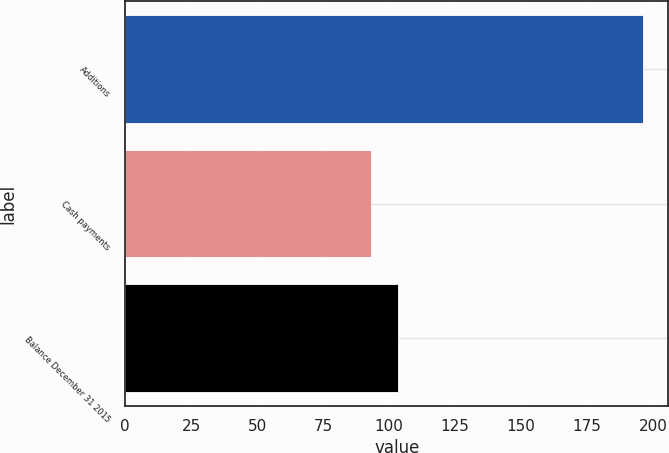Convert chart to OTSL. <chart><loc_0><loc_0><loc_500><loc_500><bar_chart><fcel>Additions<fcel>Cash payments<fcel>Balance December 31 2015<nl><fcel>196<fcel>93.1<fcel>103.39<nl></chart> 